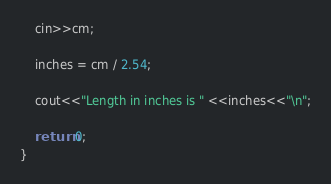Convert code to text. <code><loc_0><loc_0><loc_500><loc_500><_C++_>    cin>>cm;

    inches = cm / 2.54;

    cout<<"Length in inches is " <<inches<<"\n";

    return 0;
}  
</code> 